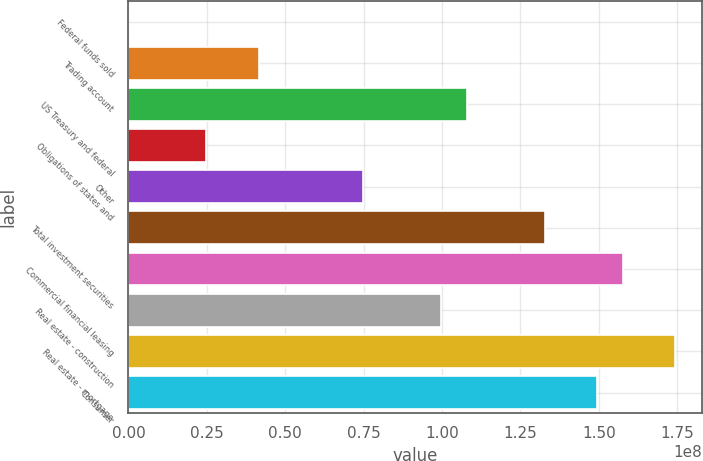Convert chart to OTSL. <chart><loc_0><loc_0><loc_500><loc_500><bar_chart><fcel>Federal funds sold<fcel>Trading account<fcel>US Treasury and federal<fcel>Obligations of states and<fcel>Other<fcel>Total investment securities<fcel>Commercial financial leasing<fcel>Real estate - construction<fcel>Real estate - mortgage<fcel>Consumer<nl><fcel>3000<fcel>4.15059e+07<fcel>1.07911e+08<fcel>2.49047e+07<fcel>7.47082e+07<fcel>1.32812e+08<fcel>1.57714e+08<fcel>9.961e+07<fcel>1.74315e+08<fcel>1.49413e+08<nl></chart> 